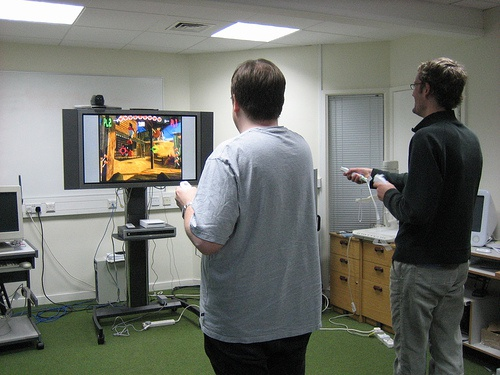Describe the objects in this image and their specific colors. I can see people in white, gray, black, lavender, and darkgray tones, people in white, black, gray, and darkgray tones, tv in white, gray, black, darkgray, and gold tones, tv in white, darkgray, black, and gray tones, and keyboard in white, gray, lightgray, darkgray, and black tones in this image. 